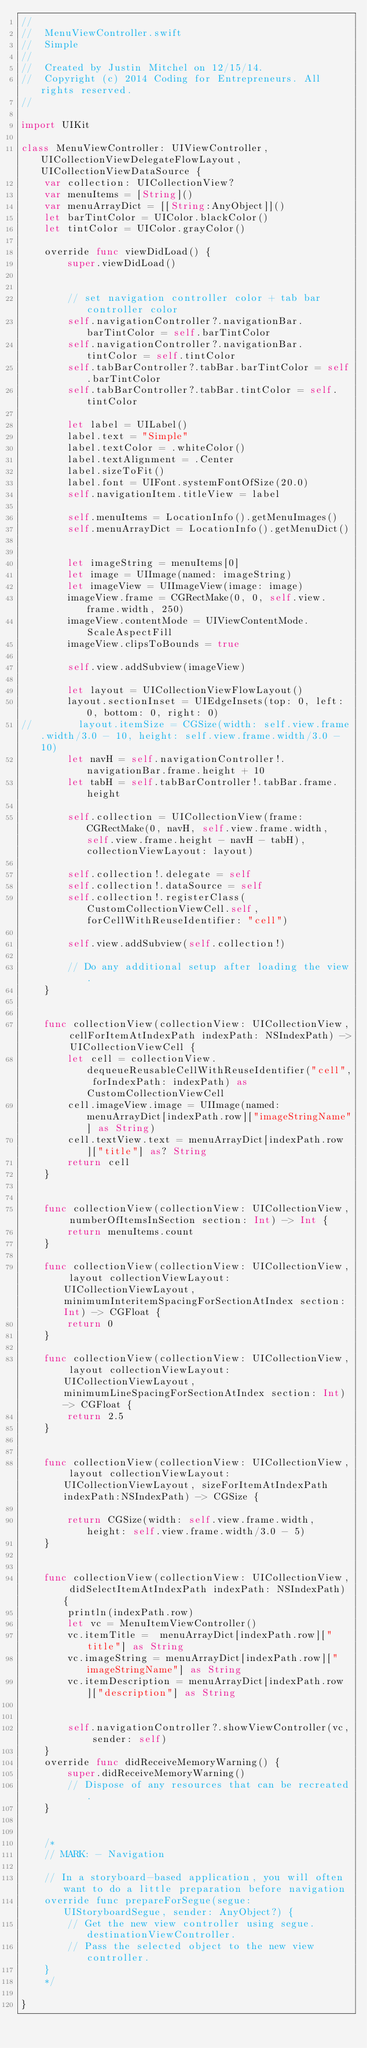Convert code to text. <code><loc_0><loc_0><loc_500><loc_500><_Swift_>//
//  MenuViewController.swift
//  Simple
//
//  Created by Justin Mitchel on 12/15/14.
//  Copyright (c) 2014 Coding for Entrepreneurs. All rights reserved.
//

import UIKit

class MenuViewController: UIViewController, UICollectionViewDelegateFlowLayout, UICollectionViewDataSource {
    var collection: UICollectionView?
    var menuItems = [String]()
    var menuArrayDict = [[String:AnyObject]]()
    let barTintColor = UIColor.blackColor()
    let tintColor = UIColor.grayColor()
    
    override func viewDidLoad() {
        super.viewDidLoad()
        
        
        // set navigation controller color + tab bar controller color
        self.navigationController?.navigationBar.barTintColor = self.barTintColor
        self.navigationController?.navigationBar.tintColor = self.tintColor
        self.tabBarController?.tabBar.barTintColor = self.barTintColor
        self.tabBarController?.tabBar.tintColor = self.tintColor
        
        let label = UILabel()
        label.text = "Simple"
        label.textColor = .whiteColor()
        label.textAlignment = .Center
        label.sizeToFit()
        label.font = UIFont.systemFontOfSize(20.0)
        self.navigationItem.titleView = label
        
        self.menuItems = LocationInfo().getMenuImages()
        self.menuArrayDict = LocationInfo().getMenuDict()
        
        
        let imageString = menuItems[0]
        let image = UIImage(named: imageString)
        let imageView = UIImageView(image: image)
        imageView.frame = CGRectMake(0, 0, self.view.frame.width, 250)
        imageView.contentMode = UIViewContentMode.ScaleAspectFill
        imageView.clipsToBounds = true
        
        self.view.addSubview(imageView)
        
        let layout = UICollectionViewFlowLayout()
        layout.sectionInset = UIEdgeInsets(top: 0, left: 0, bottom: 0, right: 0)
//        layout.itemSize = CGSize(width: self.view.frame.width/3.0 - 10, height: self.view.frame.width/3.0 - 10)
        let navH = self.navigationController!.navigationBar.frame.height + 10
        let tabH = self.tabBarController!.tabBar.frame.height
        
        self.collection = UICollectionView(frame: CGRectMake(0, navH, self.view.frame.width, self.view.frame.height - navH - tabH), collectionViewLayout: layout)
        
        self.collection!.delegate = self
        self.collection!.dataSource = self
        self.collection!.registerClass(CustomCollectionViewCell.self, forCellWithReuseIdentifier: "cell")
        
        self.view.addSubview(self.collection!)
        
        // Do any additional setup after loading the view.
    }

    
    func collectionView(collectionView: UICollectionView, cellForItemAtIndexPath indexPath: NSIndexPath) -> UICollectionViewCell {
        let cell = collectionView.dequeueReusableCellWithReuseIdentifier("cell", forIndexPath: indexPath) as CustomCollectionViewCell
        cell.imageView.image = UIImage(named: menuArrayDict[indexPath.row]["imageStringName"] as String)
        cell.textView.text = menuArrayDict[indexPath.row]["title"] as? String
        return cell
    }
    
    
    func collectionView(collectionView: UICollectionView, numberOfItemsInSection section: Int) -> Int {
        return menuItems.count
    }
    
    func collectionView(collectionView: UICollectionView, layout collectionViewLayout: UICollectionViewLayout, minimumInteritemSpacingForSectionAtIndex section: Int) -> CGFloat {
        return 0
    }
    
    func collectionView(collectionView: UICollectionView, layout collectionViewLayout: UICollectionViewLayout, minimumLineSpacingForSectionAtIndex section: Int) -> CGFloat {
        return 2.5
    }
    
    
    func collectionView(collectionView: UICollectionView, layout collectionViewLayout: UICollectionViewLayout, sizeForItemAtIndexPath indexPath:NSIndexPath) -> CGSize {
        
        return CGSize(width: self.view.frame.width, height: self.view.frame.width/3.0 - 5)
    }
    
    
    func collectionView(collectionView: UICollectionView, didSelectItemAtIndexPath indexPath: NSIndexPath) {
        println(indexPath.row)
        let vc = MenuItemViewController()
        vc.itemTitle =  menuArrayDict[indexPath.row]["title"] as String
        vc.imageString = menuArrayDict[indexPath.row]["imageStringName"] as String
        vc.itemDescription = menuArrayDict[indexPath.row]["description"] as String
    
        
        self.navigationController?.showViewController(vc, sender: self)
    }
    override func didReceiveMemoryWarning() {
        super.didReceiveMemoryWarning()
        // Dispose of any resources that can be recreated.
    }
    

    /*
    // MARK: - Navigation

    // In a storyboard-based application, you will often want to do a little preparation before navigation
    override func prepareForSegue(segue: UIStoryboardSegue, sender: AnyObject?) {
        // Get the new view controller using segue.destinationViewController.
        // Pass the selected object to the new view controller.
    }
    */

}
</code> 